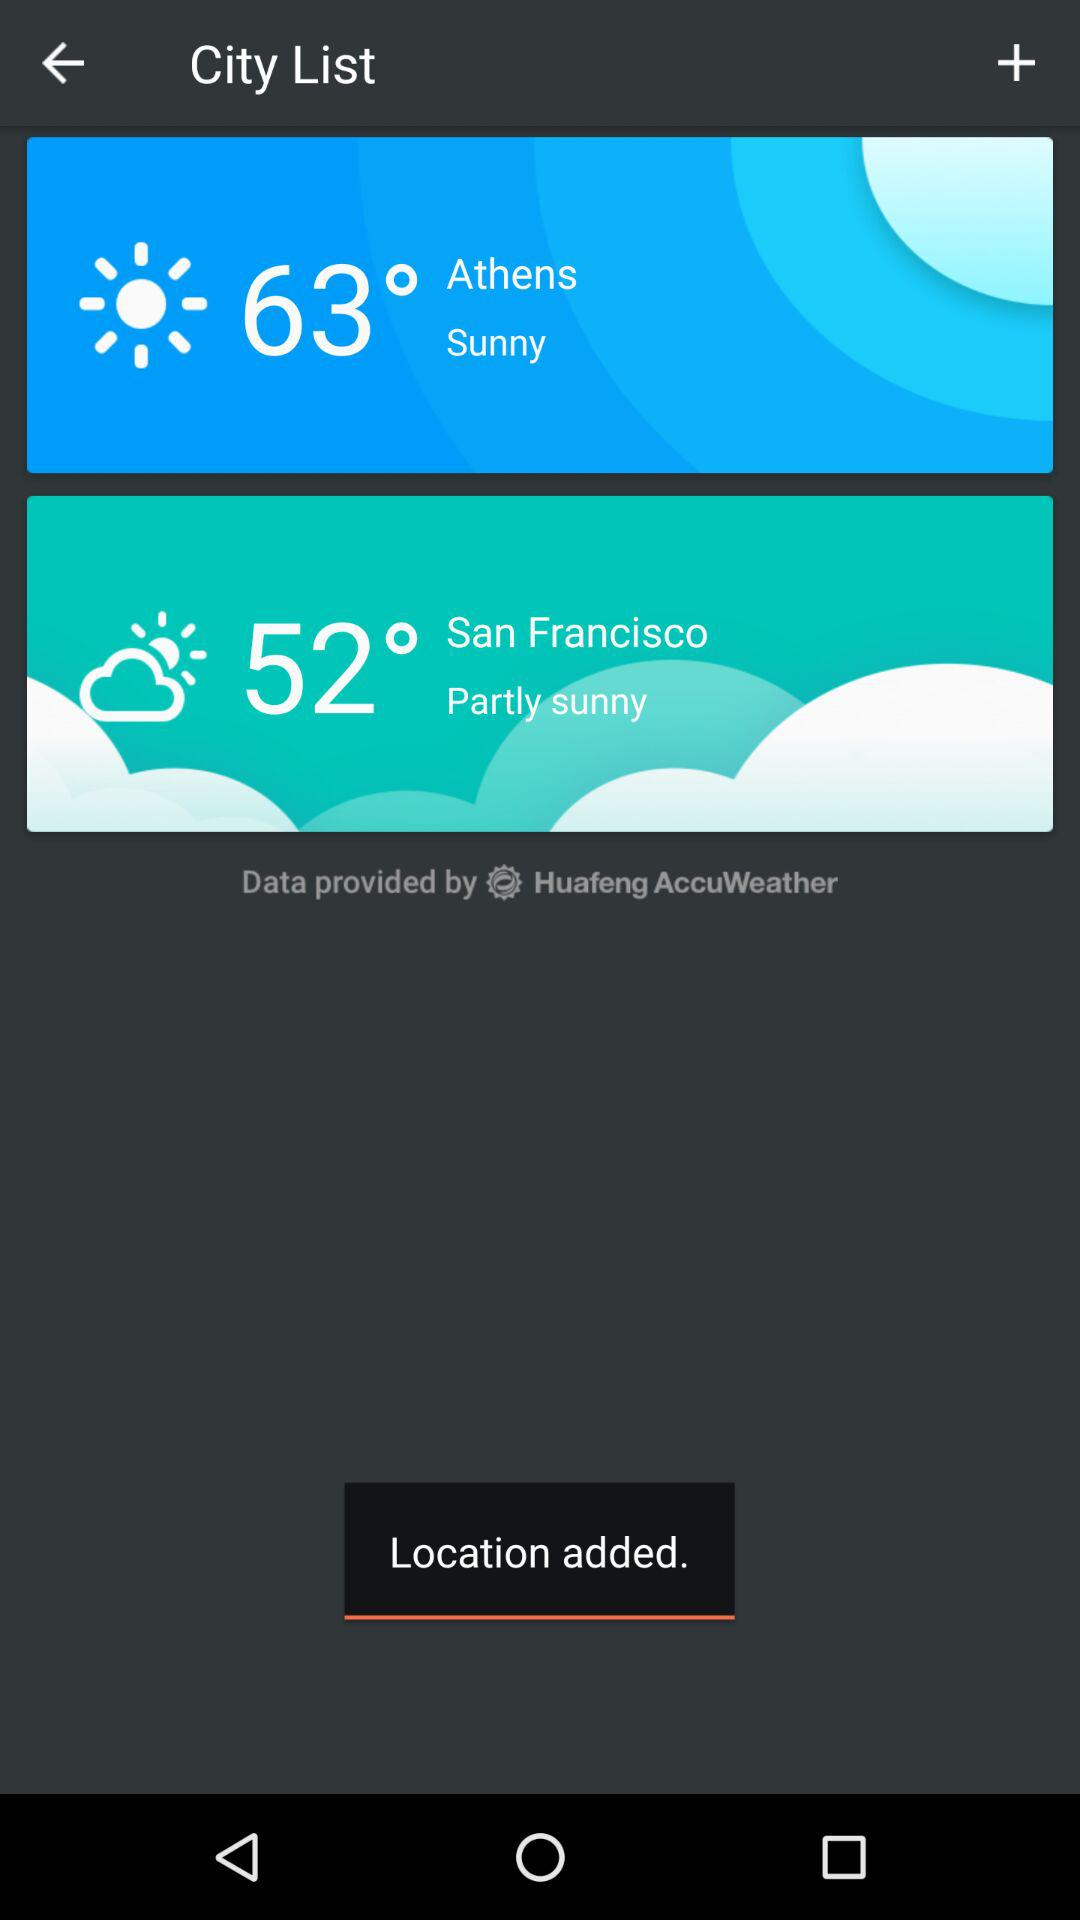What temperature is shown for San Francisco? The shown temperature for San Francisco is 52°. 